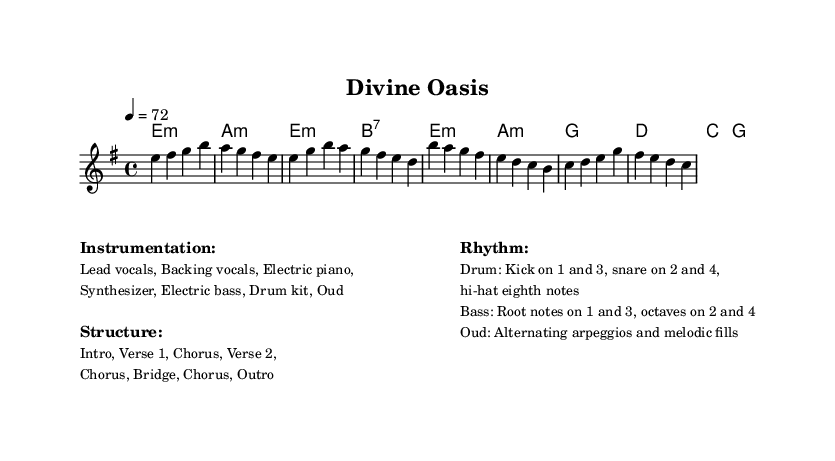What is the key signature of this music? The key signature is E minor, which has one sharp (F#).
Answer: E minor What is the time signature of this music? The time signature is 4/4, indicating four beats per measure.
Answer: 4/4 What is the tempo marking for this piece? The tempo marking is 72 beats per minute, as indicated in the score.
Answer: 72 What is the primary percussion rhythm used in this music? The primary percussion rhythm features the kick on beats 1 and 3, and the snare on beats 2 and 4, with hi-hat playing eighth notes.
Answer: Kick on 1 and 3, snare on 2 and 4 How many instruments are listed in the instrumentation? There are six instruments listed: Lead vocals, Backing vocals, Electric piano, Synthesizer, Electric bass, Drum kit, and Oud, which totals seven distinct parts.
Answer: Seven What is the structure of this piece? The structure is labeled as Intro, Verse 1, Chorus, Verse 2, Chorus, Bridge, Chorus, Outro, totaling eight sections.
Answer: Intro, Verse 1, Chorus, Verse 2, Chorus, Bridge, Chorus, Outro 